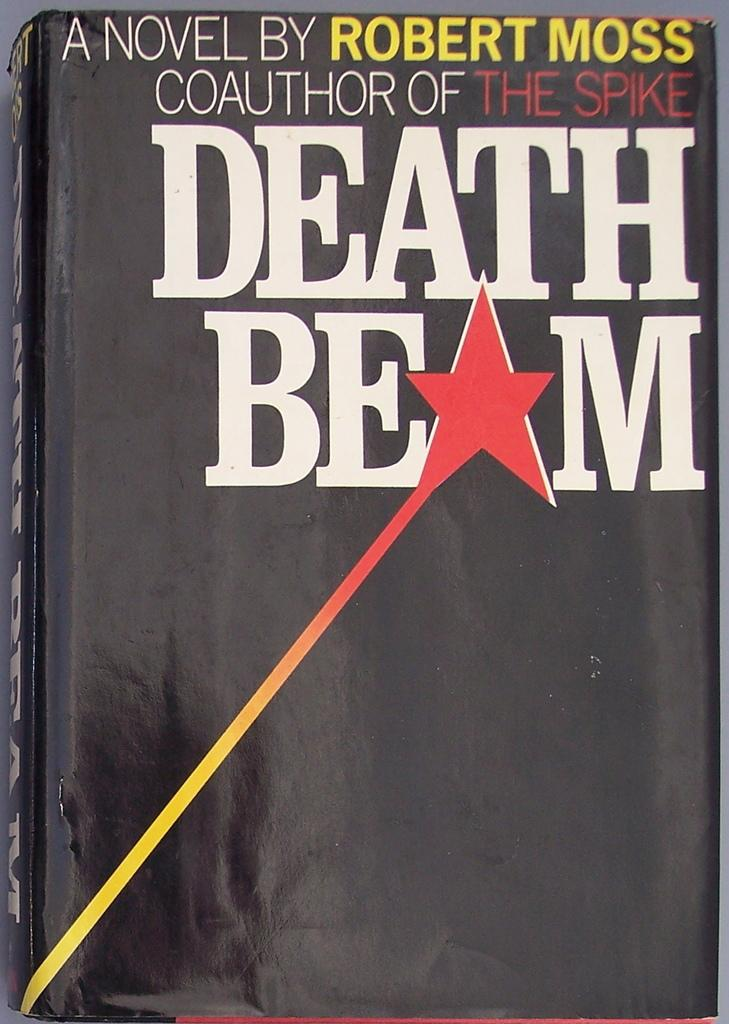<image>
Give a short and clear explanation of the subsequent image. The cover of a novel by Robert Moss shows a shooting red star 